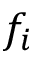Convert formula to latex. <formula><loc_0><loc_0><loc_500><loc_500>f _ { i }</formula> 